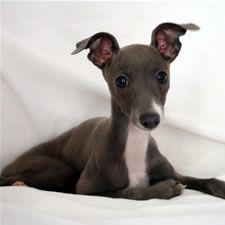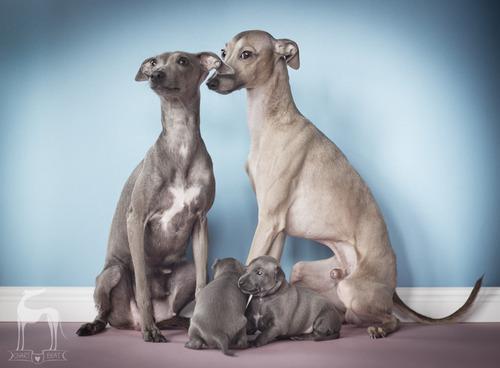The first image is the image on the left, the second image is the image on the right. Examine the images to the left and right. Is the description "At least two dogs have gray faces." accurate? Answer yes or no. Yes. 